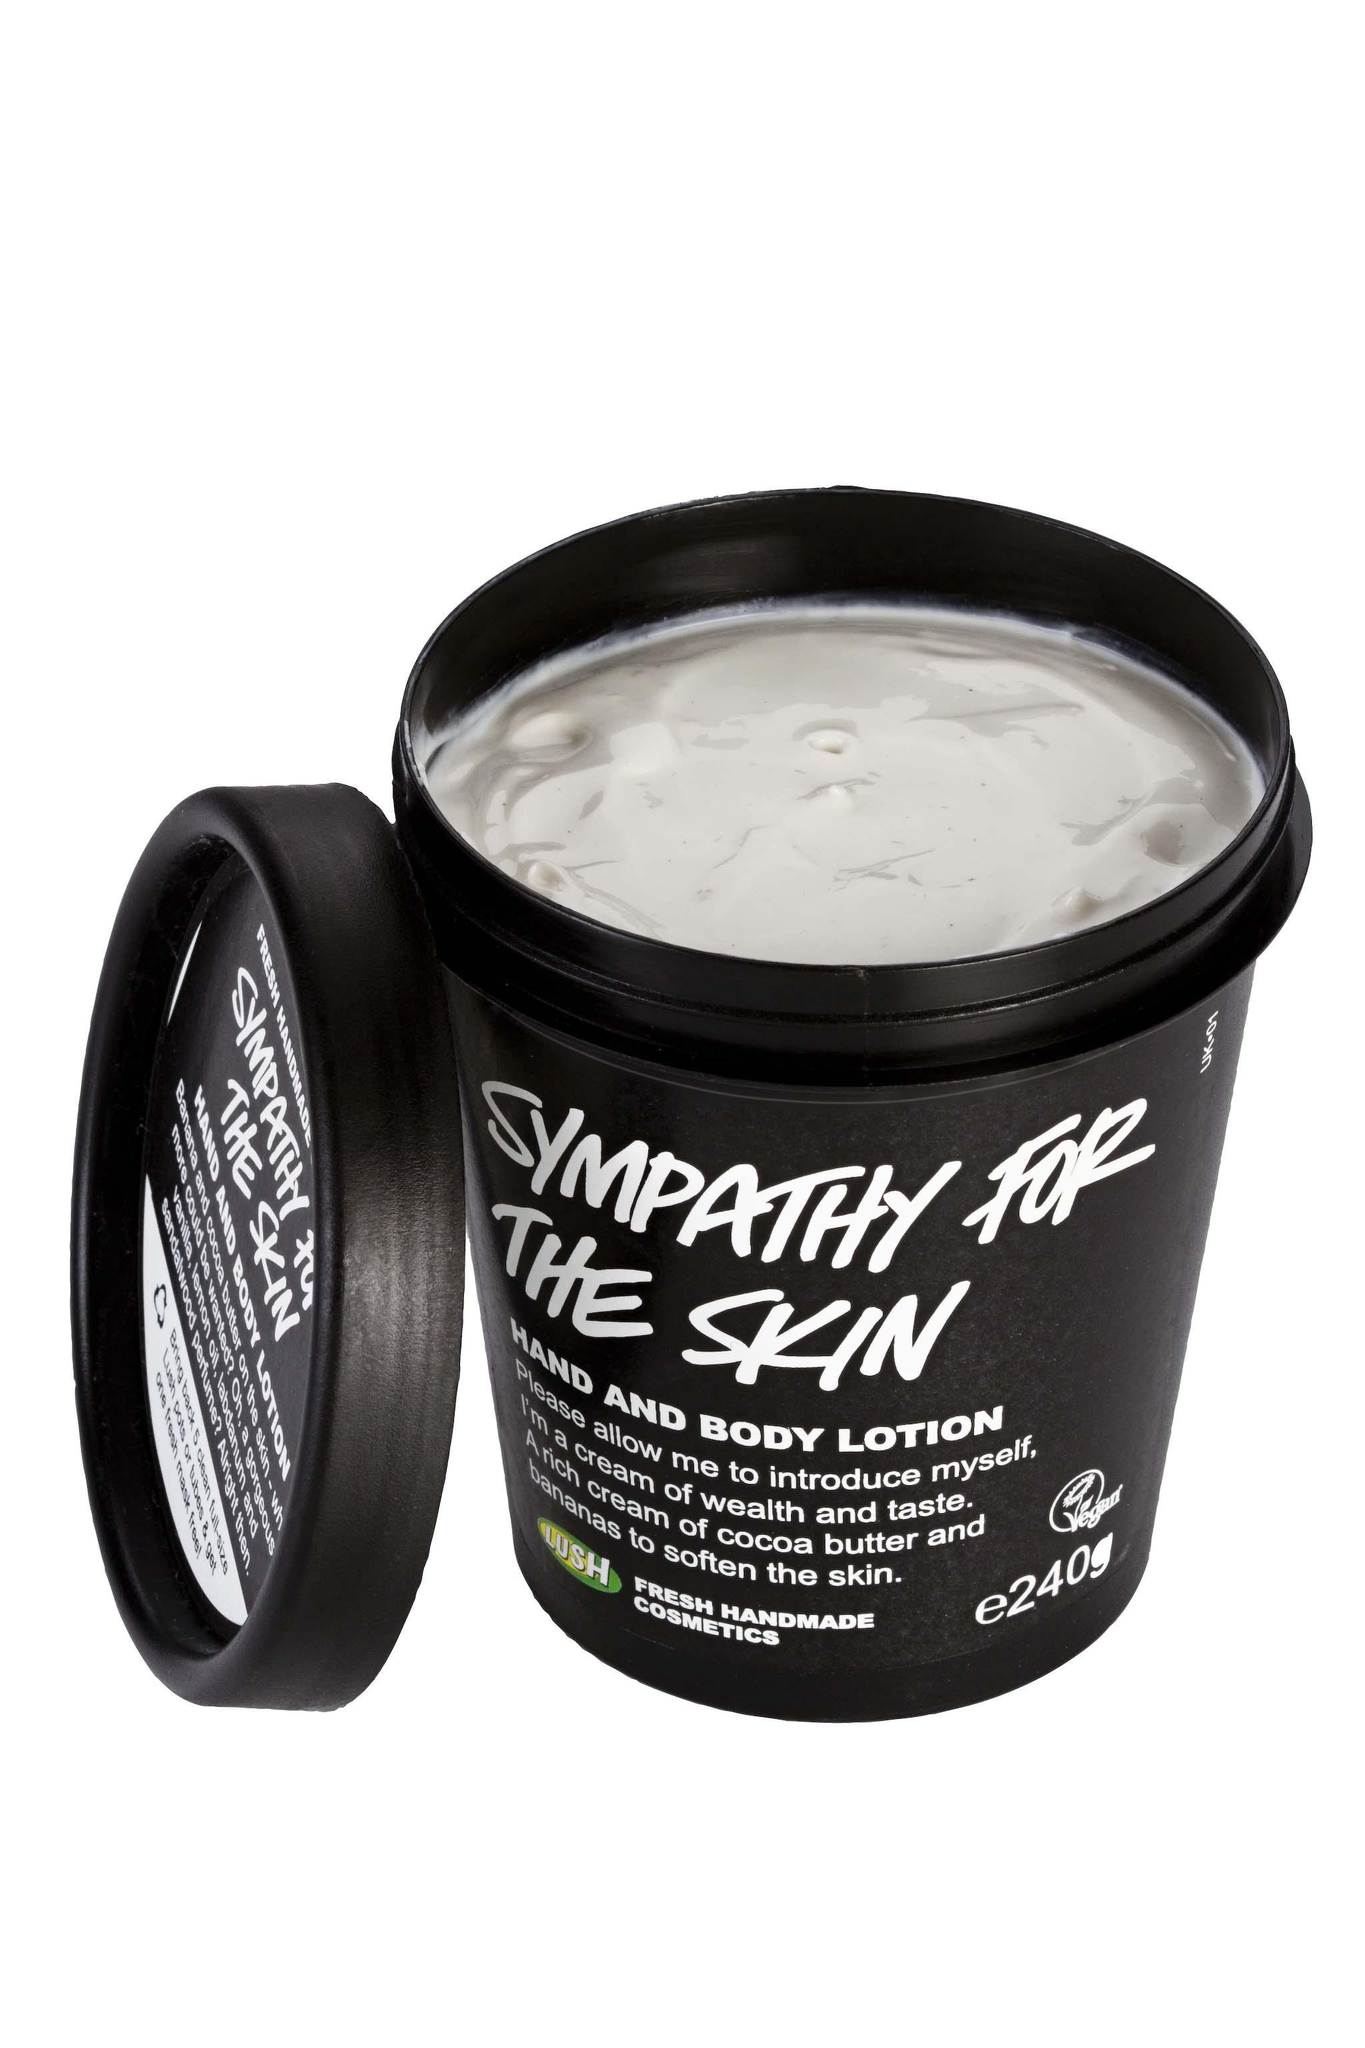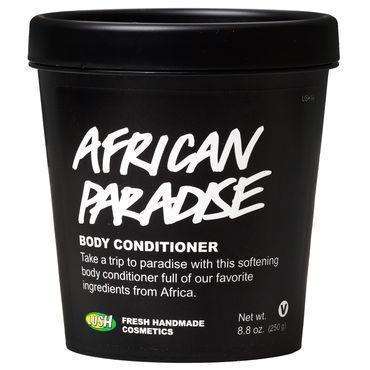The first image is the image on the left, the second image is the image on the right. Evaluate the accuracy of this statement regarding the images: "In one image, the top is on the black tub, and in the other it is off, revealing a white cream inside". Is it true? Answer yes or no. Yes. The first image is the image on the left, the second image is the image on the right. Considering the images on both sides, is "A lid is leaning next to one of the black tubs." valid? Answer yes or no. Yes. 